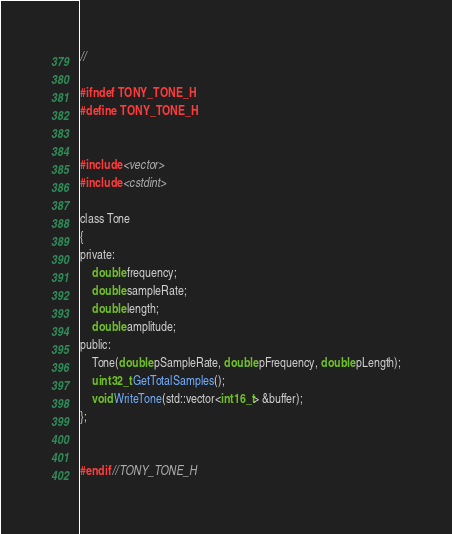Convert code to text. <code><loc_0><loc_0><loc_500><loc_500><_C_>//

#ifndef TONY_TONE_H
#define TONY_TONE_H


#include <vector>
#include <cstdint>

class Tone
{
private:
    double frequency;
    double sampleRate;
    double length;
    double amplitude;
public:
    Tone(double pSampleRate, double pFrequency, double pLength);
    uint32_t GetTotalSamples();
    void WriteTone(std::vector<int16_t> &buffer);
};


#endif //TONY_TONE_H
</code> 